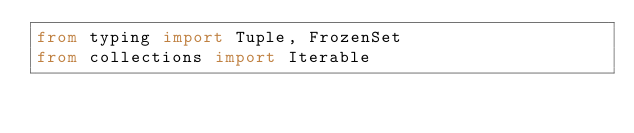Convert code to text. <code><loc_0><loc_0><loc_500><loc_500><_Python_>from typing import Tuple, FrozenSet
from collections import Iterable
</code> 